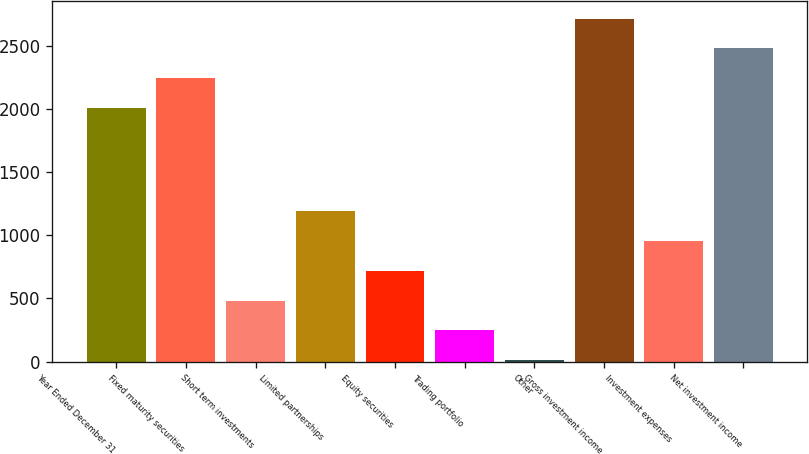Convert chart. <chart><loc_0><loc_0><loc_500><loc_500><bar_chart><fcel>Year Ended December 31<fcel>Fixed maturity securities<fcel>Short term investments<fcel>Limited partnerships<fcel>Equity securities<fcel>Trading portfolio<fcel>Other<fcel>Gross investment income<fcel>Investment expenses<fcel>Net investment income<nl><fcel>2010<fcel>2246<fcel>482<fcel>1190<fcel>718<fcel>246<fcel>10<fcel>2718<fcel>954<fcel>2482<nl></chart> 